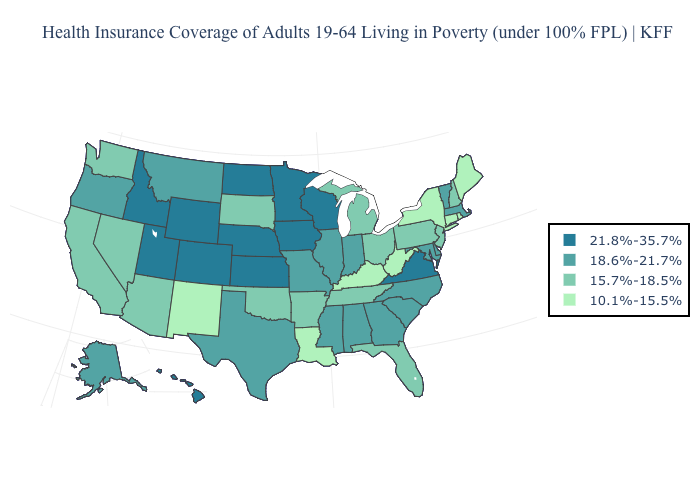How many symbols are there in the legend?
Concise answer only. 4. Is the legend a continuous bar?
Short answer required. No. Name the states that have a value in the range 21.8%-35.7%?
Quick response, please. Colorado, Hawaii, Idaho, Iowa, Kansas, Minnesota, Nebraska, North Dakota, Utah, Virginia, Wisconsin, Wyoming. Does Washington have the lowest value in the USA?
Concise answer only. No. What is the value of Missouri?
Write a very short answer. 18.6%-21.7%. Which states hav the highest value in the Northeast?
Keep it brief. Massachusetts, Vermont. What is the highest value in the South ?
Write a very short answer. 21.8%-35.7%. What is the value of Vermont?
Be succinct. 18.6%-21.7%. What is the highest value in the USA?
Quick response, please. 21.8%-35.7%. What is the lowest value in states that border North Carolina?
Short answer required. 15.7%-18.5%. Name the states that have a value in the range 10.1%-15.5%?
Keep it brief. Connecticut, Kentucky, Louisiana, Maine, New Mexico, New York, Rhode Island, West Virginia. What is the value of Arizona?
Give a very brief answer. 15.7%-18.5%. What is the lowest value in the USA?
Give a very brief answer. 10.1%-15.5%. Is the legend a continuous bar?
Give a very brief answer. No. What is the value of Maine?
Quick response, please. 10.1%-15.5%. 